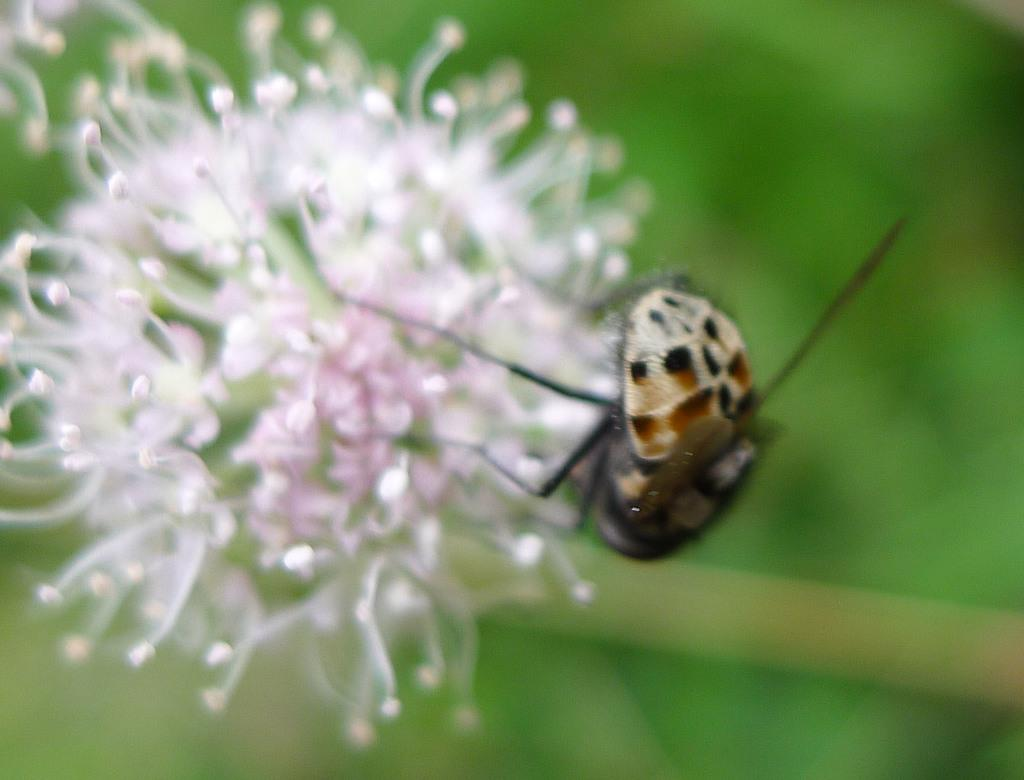What is the overall quality of the image? The image is blurry. What can be seen in the image despite the blurriness? There is an insect in the image. Where is the insect located in the image? The insect is on flowers. What color is the background of the image? The background of the image is green. What is the belief system of the dinosaurs in the image? There are no dinosaurs present in the image, so it is not possible to determine their belief system. 